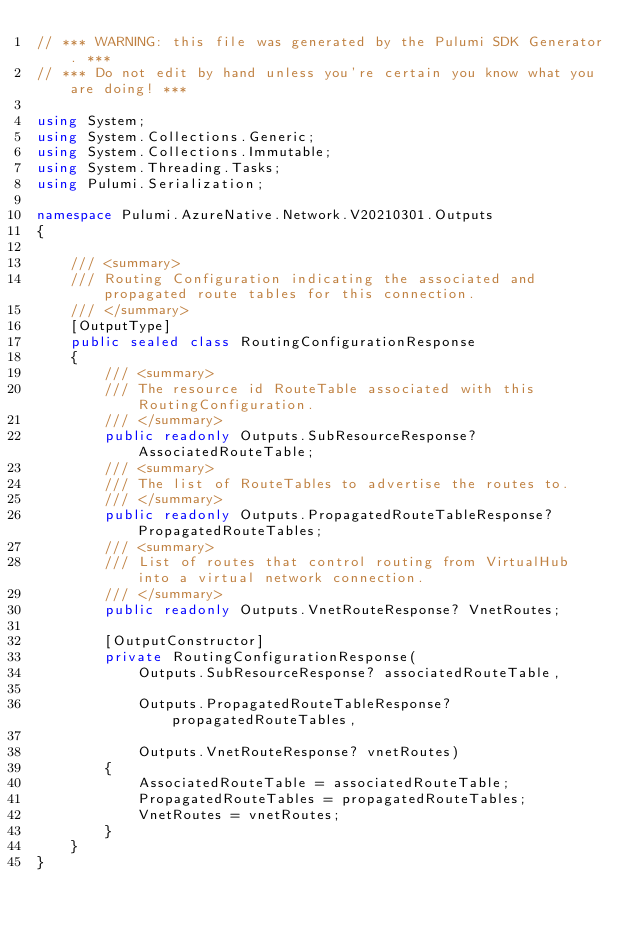<code> <loc_0><loc_0><loc_500><loc_500><_C#_>// *** WARNING: this file was generated by the Pulumi SDK Generator. ***
// *** Do not edit by hand unless you're certain you know what you are doing! ***

using System;
using System.Collections.Generic;
using System.Collections.Immutable;
using System.Threading.Tasks;
using Pulumi.Serialization;

namespace Pulumi.AzureNative.Network.V20210301.Outputs
{

    /// <summary>
    /// Routing Configuration indicating the associated and propagated route tables for this connection.
    /// </summary>
    [OutputType]
    public sealed class RoutingConfigurationResponse
    {
        /// <summary>
        /// The resource id RouteTable associated with this RoutingConfiguration.
        /// </summary>
        public readonly Outputs.SubResourceResponse? AssociatedRouteTable;
        /// <summary>
        /// The list of RouteTables to advertise the routes to.
        /// </summary>
        public readonly Outputs.PropagatedRouteTableResponse? PropagatedRouteTables;
        /// <summary>
        /// List of routes that control routing from VirtualHub into a virtual network connection.
        /// </summary>
        public readonly Outputs.VnetRouteResponse? VnetRoutes;

        [OutputConstructor]
        private RoutingConfigurationResponse(
            Outputs.SubResourceResponse? associatedRouteTable,

            Outputs.PropagatedRouteTableResponse? propagatedRouteTables,

            Outputs.VnetRouteResponse? vnetRoutes)
        {
            AssociatedRouteTable = associatedRouteTable;
            PropagatedRouteTables = propagatedRouteTables;
            VnetRoutes = vnetRoutes;
        }
    }
}
</code> 